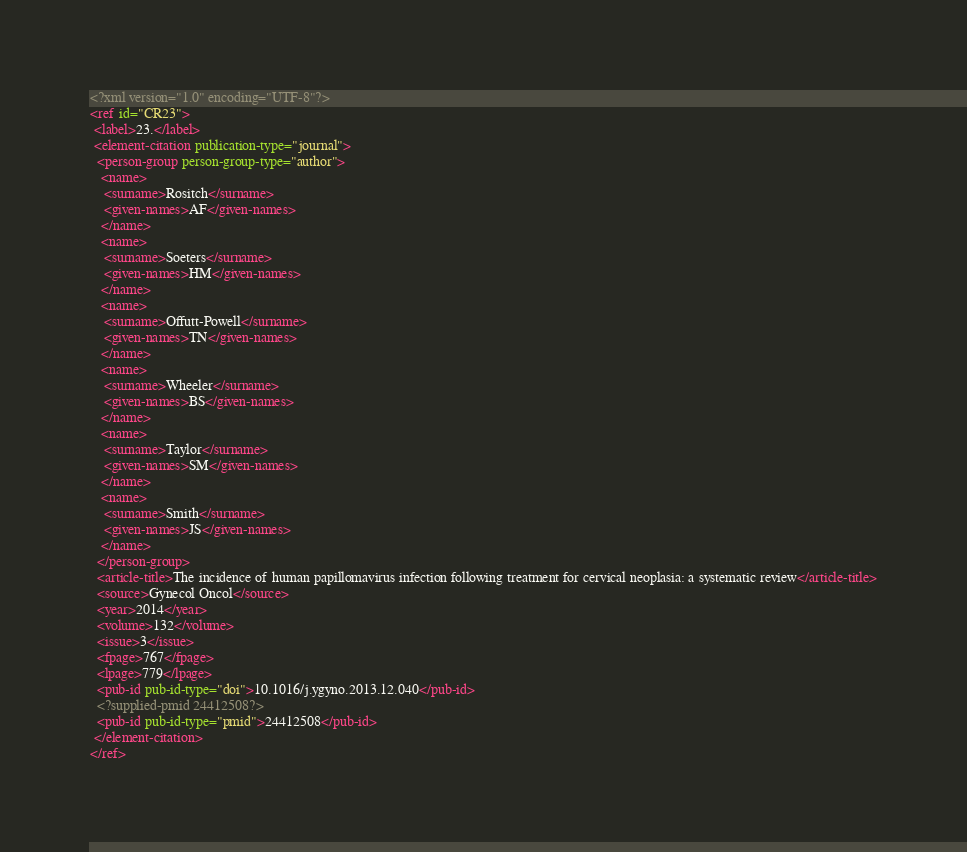Convert code to text. <code><loc_0><loc_0><loc_500><loc_500><_XML_><?xml version="1.0" encoding="UTF-8"?>
<ref id="CR23">
 <label>23.</label>
 <element-citation publication-type="journal">
  <person-group person-group-type="author">
   <name>
    <surname>Rositch</surname>
    <given-names>AF</given-names>
   </name>
   <name>
    <surname>Soeters</surname>
    <given-names>HM</given-names>
   </name>
   <name>
    <surname>Offutt-Powell</surname>
    <given-names>TN</given-names>
   </name>
   <name>
    <surname>Wheeler</surname>
    <given-names>BS</given-names>
   </name>
   <name>
    <surname>Taylor</surname>
    <given-names>SM</given-names>
   </name>
   <name>
    <surname>Smith</surname>
    <given-names>JS</given-names>
   </name>
  </person-group>
  <article-title>The incidence of human papillomavirus infection following treatment for cervical neoplasia: a systematic review</article-title>
  <source>Gynecol Oncol</source>
  <year>2014</year>
  <volume>132</volume>
  <issue>3</issue>
  <fpage>767</fpage>
  <lpage>779</lpage>
  <pub-id pub-id-type="doi">10.1016/j.ygyno.2013.12.040</pub-id>
  <?supplied-pmid 24412508?>
  <pub-id pub-id-type="pmid">24412508</pub-id>
 </element-citation>
</ref>
</code> 